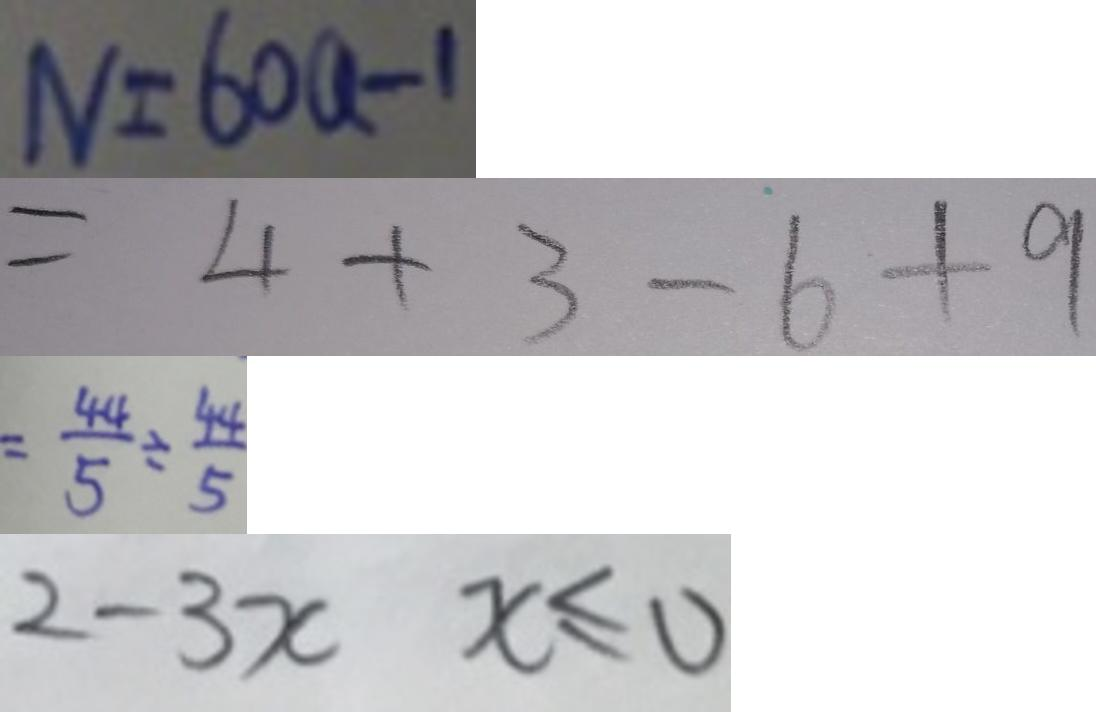<formula> <loc_0><loc_0><loc_500><loc_500>N = 6 0 a - 1 
 = 4 + 3 - 6 + 9 
 = \frac { 4 4 } { 5 } \div \frac { 4 4 } { 5 } 
 2 - 3 x x \leq 0</formula> 